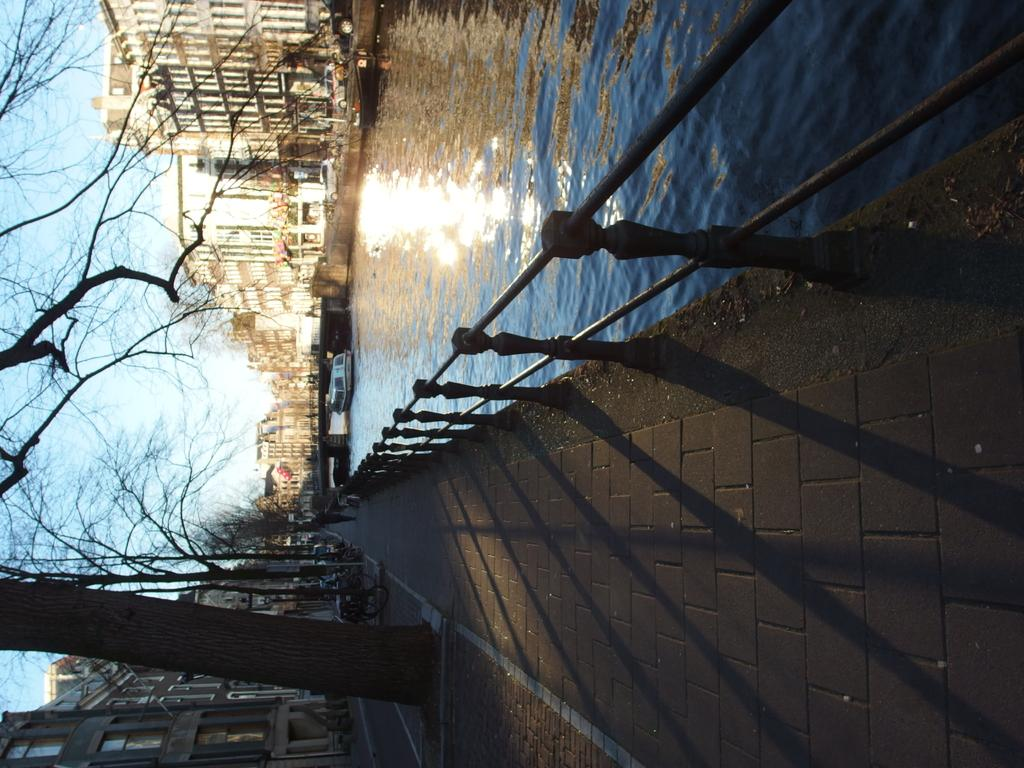What can be seen on the surface of the lake in the image? There are two boats on the surface of the lake in the image. What type of natural environment is depicted in the image? There are many trees in the image, indicating a natural setting. What type of structures are visible in the image? There are buildings in the image. What part of the sky is visible in the image? The sky is visible in the image. What can be used for walking in the image? There is a path for walking in the image. Can you hear the bells ringing in the image? There are no bells present in the image, so it is not possible to hear them ringing. Is there a plane flying in the image? There is no plane visible in the image. 